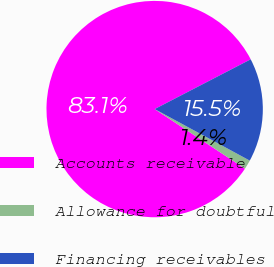Convert chart to OTSL. <chart><loc_0><loc_0><loc_500><loc_500><pie_chart><fcel>Accounts receivable<fcel>Allowance for doubtful<fcel>Financing receivables<nl><fcel>83.11%<fcel>1.38%<fcel>15.51%<nl></chart> 